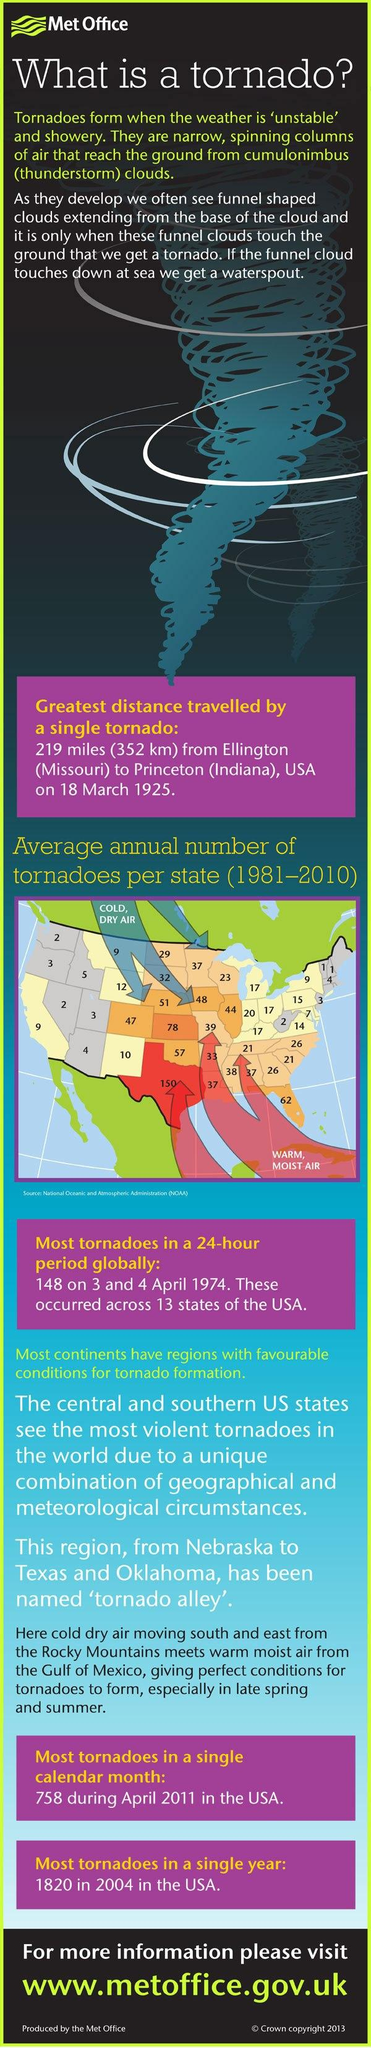List a handful of essential elements in this visual. According to data collected during the period of 1981 to 2010, the state with the highest average annual number of tornadoes is Texas. During the period of 1981 to 2010, the average annual number of tornadoes in New Mexico was approximately 10. During the period of 1981 to 2010, the state of Kansas reported the second-highest average annual number of tornadoes, with an average of approximately 65 tornadoes per year. During the period of 1981 to 2010, the average annual number of tornadoes in California was approximately 9. 